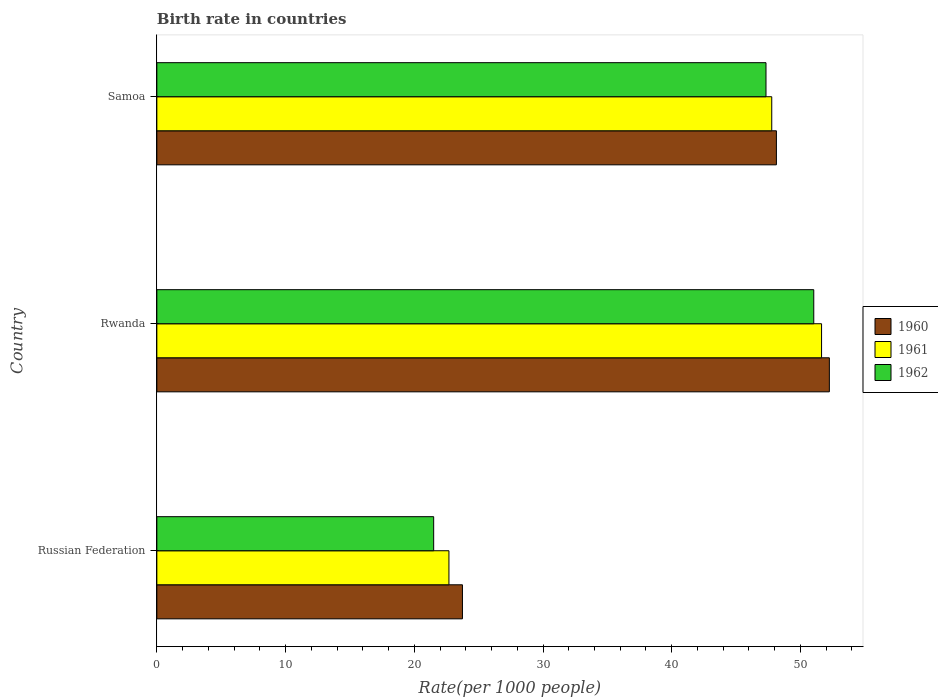How many different coloured bars are there?
Provide a succinct answer. 3. How many groups of bars are there?
Ensure brevity in your answer.  3. Are the number of bars per tick equal to the number of legend labels?
Provide a succinct answer. Yes. How many bars are there on the 2nd tick from the top?
Your answer should be compact. 3. How many bars are there on the 2nd tick from the bottom?
Your response must be concise. 3. What is the label of the 1st group of bars from the top?
Keep it short and to the point. Samoa. What is the birth rate in 1961 in Rwanda?
Make the answer very short. 51.64. Across all countries, what is the maximum birth rate in 1962?
Provide a short and direct response. 51.04. Across all countries, what is the minimum birth rate in 1962?
Your response must be concise. 21.51. In which country was the birth rate in 1962 maximum?
Give a very brief answer. Rwanda. In which country was the birth rate in 1960 minimum?
Offer a very short reply. Russian Federation. What is the total birth rate in 1961 in the graph?
Make the answer very short. 122.11. What is the difference between the birth rate in 1961 in Rwanda and that in Samoa?
Make the answer very short. 3.87. What is the difference between the birth rate in 1962 in Russian Federation and the birth rate in 1960 in Samoa?
Keep it short and to the point. -26.63. What is the average birth rate in 1960 per country?
Ensure brevity in your answer.  41.37. What is the difference between the birth rate in 1961 and birth rate in 1960 in Samoa?
Offer a very short reply. -0.36. In how many countries, is the birth rate in 1961 greater than 28 ?
Make the answer very short. 2. What is the ratio of the birth rate in 1960 in Russian Federation to that in Samoa?
Your answer should be very brief. 0.49. What is the difference between the highest and the second highest birth rate in 1961?
Your answer should be very brief. 3.87. What is the difference between the highest and the lowest birth rate in 1962?
Your response must be concise. 29.53. How many bars are there?
Your answer should be very brief. 9. What is the difference between two consecutive major ticks on the X-axis?
Your response must be concise. 10. Does the graph contain any zero values?
Keep it short and to the point. No. Does the graph contain grids?
Offer a very short reply. No. How are the legend labels stacked?
Offer a very short reply. Vertical. What is the title of the graph?
Offer a terse response. Birth rate in countries. What is the label or title of the X-axis?
Provide a short and direct response. Rate(per 1000 people). What is the Rate(per 1000 people) of 1960 in Russian Federation?
Your answer should be very brief. 23.74. What is the Rate(per 1000 people) of 1961 in Russian Federation?
Your answer should be compact. 22.69. What is the Rate(per 1000 people) of 1962 in Russian Federation?
Provide a short and direct response. 21.51. What is the Rate(per 1000 people) of 1960 in Rwanda?
Keep it short and to the point. 52.25. What is the Rate(per 1000 people) of 1961 in Rwanda?
Ensure brevity in your answer.  51.64. What is the Rate(per 1000 people) of 1962 in Rwanda?
Your answer should be very brief. 51.04. What is the Rate(per 1000 people) of 1960 in Samoa?
Your answer should be very brief. 48.13. What is the Rate(per 1000 people) of 1961 in Samoa?
Offer a very short reply. 47.77. What is the Rate(per 1000 people) in 1962 in Samoa?
Keep it short and to the point. 47.33. Across all countries, what is the maximum Rate(per 1000 people) in 1960?
Make the answer very short. 52.25. Across all countries, what is the maximum Rate(per 1000 people) in 1961?
Your response must be concise. 51.64. Across all countries, what is the maximum Rate(per 1000 people) of 1962?
Your answer should be compact. 51.04. Across all countries, what is the minimum Rate(per 1000 people) of 1960?
Keep it short and to the point. 23.74. Across all countries, what is the minimum Rate(per 1000 people) in 1961?
Keep it short and to the point. 22.69. Across all countries, what is the minimum Rate(per 1000 people) in 1962?
Offer a terse response. 21.51. What is the total Rate(per 1000 people) of 1960 in the graph?
Ensure brevity in your answer.  124.12. What is the total Rate(per 1000 people) of 1961 in the graph?
Offer a terse response. 122.11. What is the total Rate(per 1000 people) of 1962 in the graph?
Offer a very short reply. 119.87. What is the difference between the Rate(per 1000 people) of 1960 in Russian Federation and that in Rwanda?
Provide a succinct answer. -28.5. What is the difference between the Rate(per 1000 people) of 1961 in Russian Federation and that in Rwanda?
Make the answer very short. -28.95. What is the difference between the Rate(per 1000 people) in 1962 in Russian Federation and that in Rwanda?
Ensure brevity in your answer.  -29.53. What is the difference between the Rate(per 1000 people) of 1960 in Russian Federation and that in Samoa?
Ensure brevity in your answer.  -24.39. What is the difference between the Rate(per 1000 people) of 1961 in Russian Federation and that in Samoa?
Offer a terse response. -25.08. What is the difference between the Rate(per 1000 people) in 1962 in Russian Federation and that in Samoa?
Ensure brevity in your answer.  -25.82. What is the difference between the Rate(per 1000 people) in 1960 in Rwanda and that in Samoa?
Provide a short and direct response. 4.12. What is the difference between the Rate(per 1000 people) of 1961 in Rwanda and that in Samoa?
Offer a very short reply. 3.87. What is the difference between the Rate(per 1000 people) in 1962 in Rwanda and that in Samoa?
Offer a very short reply. 3.71. What is the difference between the Rate(per 1000 people) in 1960 in Russian Federation and the Rate(per 1000 people) in 1961 in Rwanda?
Your response must be concise. -27.9. What is the difference between the Rate(per 1000 people) of 1960 in Russian Federation and the Rate(per 1000 people) of 1962 in Rwanda?
Your answer should be compact. -27.29. What is the difference between the Rate(per 1000 people) of 1961 in Russian Federation and the Rate(per 1000 people) of 1962 in Rwanda?
Keep it short and to the point. -28.34. What is the difference between the Rate(per 1000 people) of 1960 in Russian Federation and the Rate(per 1000 people) of 1961 in Samoa?
Offer a very short reply. -24.03. What is the difference between the Rate(per 1000 people) of 1960 in Russian Federation and the Rate(per 1000 people) of 1962 in Samoa?
Keep it short and to the point. -23.58. What is the difference between the Rate(per 1000 people) in 1961 in Russian Federation and the Rate(per 1000 people) in 1962 in Samoa?
Give a very brief answer. -24.63. What is the difference between the Rate(per 1000 people) of 1960 in Rwanda and the Rate(per 1000 people) of 1961 in Samoa?
Ensure brevity in your answer.  4.48. What is the difference between the Rate(per 1000 people) in 1960 in Rwanda and the Rate(per 1000 people) in 1962 in Samoa?
Your answer should be very brief. 4.92. What is the difference between the Rate(per 1000 people) of 1961 in Rwanda and the Rate(per 1000 people) of 1962 in Samoa?
Offer a terse response. 4.32. What is the average Rate(per 1000 people) in 1960 per country?
Provide a short and direct response. 41.37. What is the average Rate(per 1000 people) in 1961 per country?
Offer a very short reply. 40.7. What is the average Rate(per 1000 people) of 1962 per country?
Keep it short and to the point. 39.96. What is the difference between the Rate(per 1000 people) in 1960 and Rate(per 1000 people) in 1961 in Russian Federation?
Ensure brevity in your answer.  1.05. What is the difference between the Rate(per 1000 people) in 1960 and Rate(per 1000 people) in 1962 in Russian Federation?
Your answer should be compact. 2.24. What is the difference between the Rate(per 1000 people) in 1961 and Rate(per 1000 people) in 1962 in Russian Federation?
Offer a very short reply. 1.19. What is the difference between the Rate(per 1000 people) of 1960 and Rate(per 1000 people) of 1961 in Rwanda?
Offer a very short reply. 0.61. What is the difference between the Rate(per 1000 people) in 1960 and Rate(per 1000 people) in 1962 in Rwanda?
Provide a short and direct response. 1.21. What is the difference between the Rate(per 1000 people) in 1961 and Rate(per 1000 people) in 1962 in Rwanda?
Provide a succinct answer. 0.61. What is the difference between the Rate(per 1000 people) in 1960 and Rate(per 1000 people) in 1961 in Samoa?
Your answer should be very brief. 0.36. What is the difference between the Rate(per 1000 people) in 1960 and Rate(per 1000 people) in 1962 in Samoa?
Give a very brief answer. 0.81. What is the difference between the Rate(per 1000 people) in 1961 and Rate(per 1000 people) in 1962 in Samoa?
Offer a terse response. 0.45. What is the ratio of the Rate(per 1000 people) in 1960 in Russian Federation to that in Rwanda?
Provide a short and direct response. 0.45. What is the ratio of the Rate(per 1000 people) in 1961 in Russian Federation to that in Rwanda?
Offer a terse response. 0.44. What is the ratio of the Rate(per 1000 people) in 1962 in Russian Federation to that in Rwanda?
Provide a succinct answer. 0.42. What is the ratio of the Rate(per 1000 people) of 1960 in Russian Federation to that in Samoa?
Your answer should be very brief. 0.49. What is the ratio of the Rate(per 1000 people) of 1961 in Russian Federation to that in Samoa?
Provide a succinct answer. 0.47. What is the ratio of the Rate(per 1000 people) of 1962 in Russian Federation to that in Samoa?
Give a very brief answer. 0.45. What is the ratio of the Rate(per 1000 people) of 1960 in Rwanda to that in Samoa?
Your response must be concise. 1.09. What is the ratio of the Rate(per 1000 people) in 1961 in Rwanda to that in Samoa?
Give a very brief answer. 1.08. What is the ratio of the Rate(per 1000 people) of 1962 in Rwanda to that in Samoa?
Offer a very short reply. 1.08. What is the difference between the highest and the second highest Rate(per 1000 people) in 1960?
Provide a short and direct response. 4.12. What is the difference between the highest and the second highest Rate(per 1000 people) of 1961?
Offer a terse response. 3.87. What is the difference between the highest and the second highest Rate(per 1000 people) of 1962?
Your response must be concise. 3.71. What is the difference between the highest and the lowest Rate(per 1000 people) in 1960?
Offer a very short reply. 28.5. What is the difference between the highest and the lowest Rate(per 1000 people) of 1961?
Give a very brief answer. 28.95. What is the difference between the highest and the lowest Rate(per 1000 people) in 1962?
Your answer should be very brief. 29.53. 